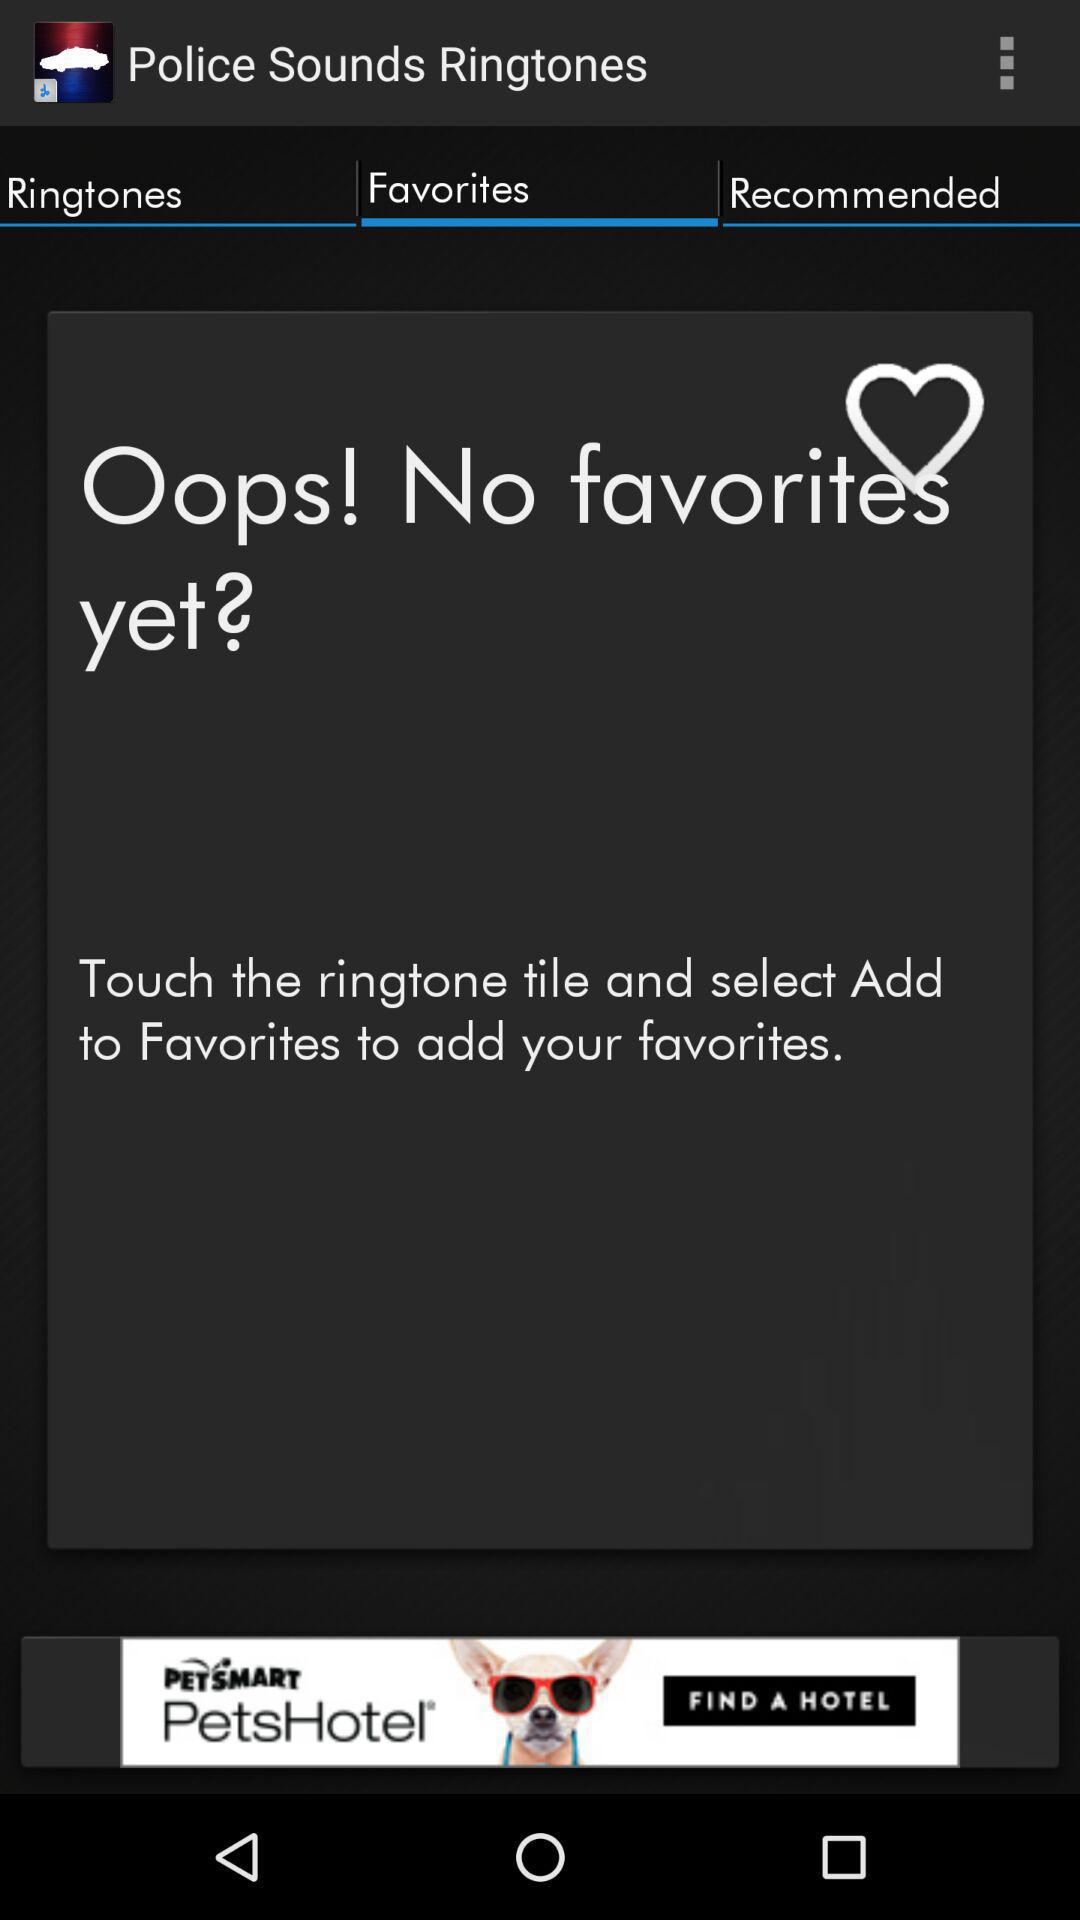Which tab is selected? The selected tab is "Favorites". 